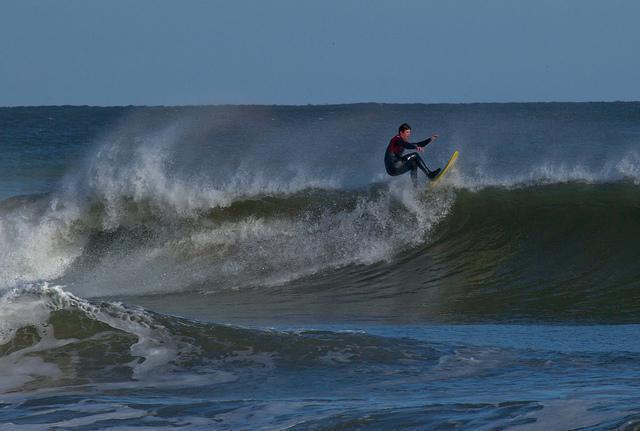How many of the birds are sitting?
Give a very brief answer. 0. 